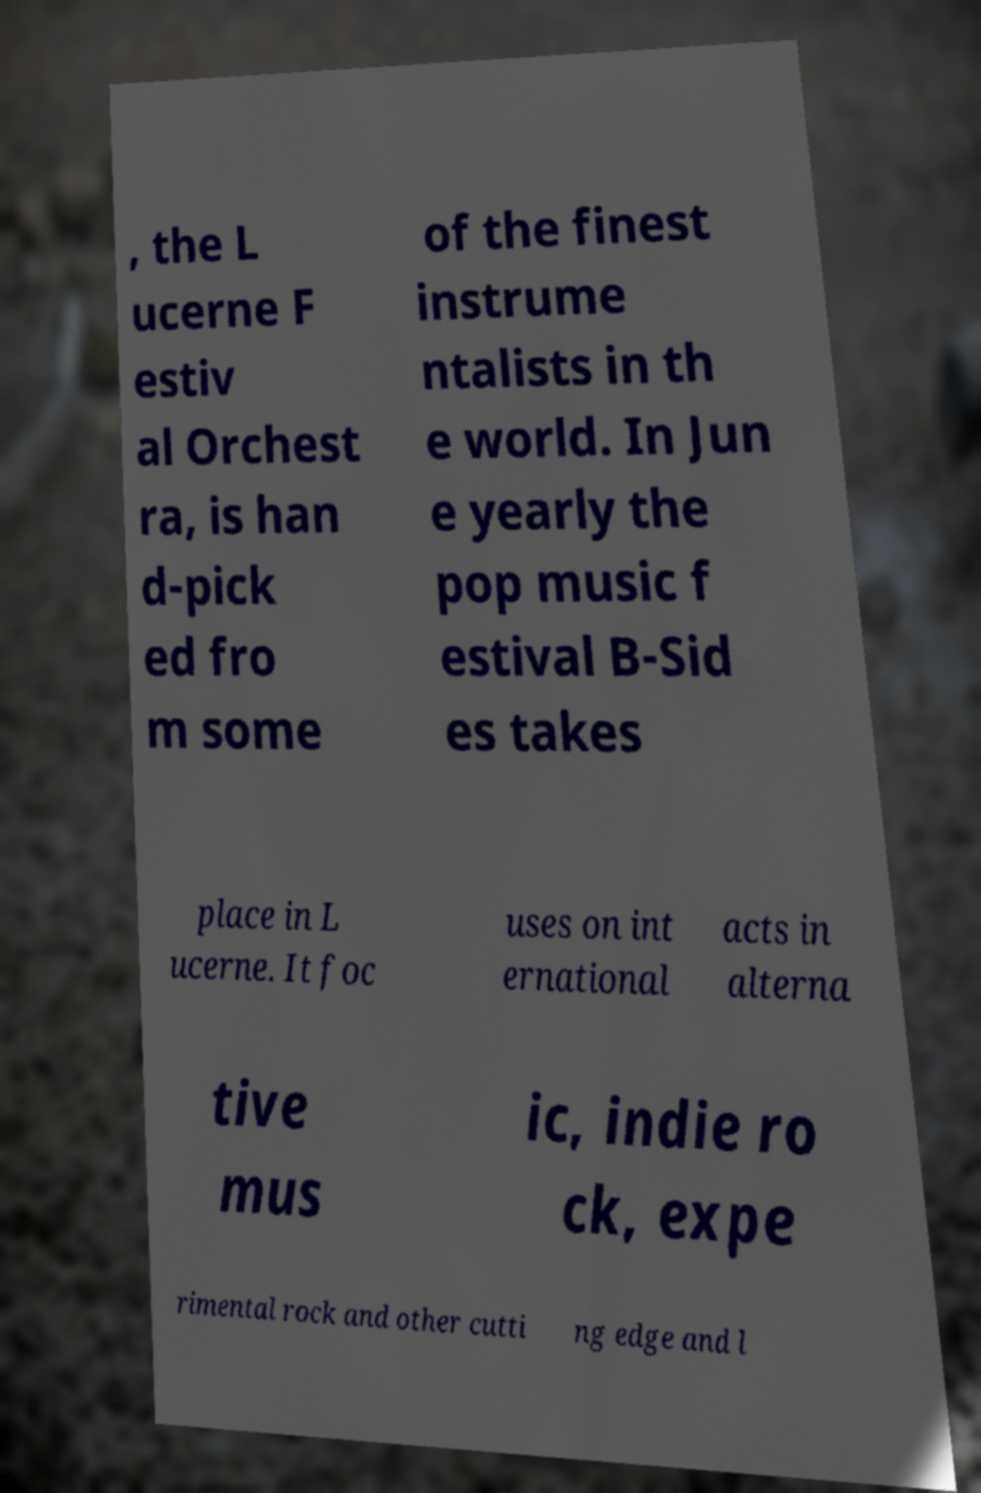Please read and relay the text visible in this image. What does it say? , the L ucerne F estiv al Orchest ra, is han d-pick ed fro m some of the finest instrume ntalists in th e world. In Jun e yearly the pop music f estival B-Sid es takes place in L ucerne. It foc uses on int ernational acts in alterna tive mus ic, indie ro ck, expe rimental rock and other cutti ng edge and l 